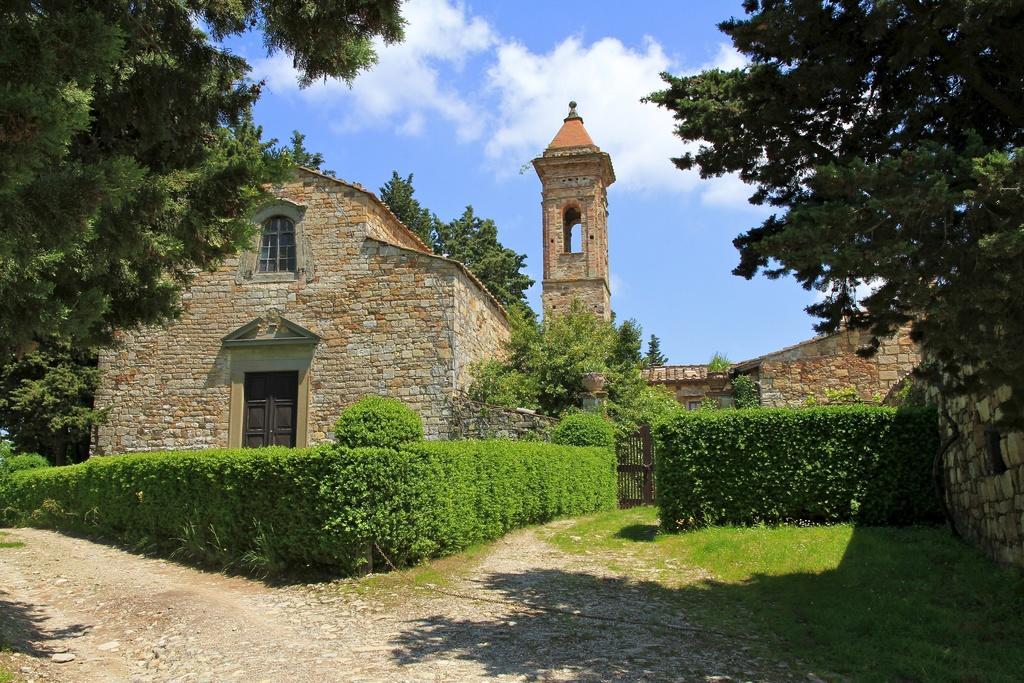How would you summarize this image in a sentence or two? There are some plants at the bottom of this image and there is a house in the background. There are some trees on the left side of this image and right side of this image as well. There is a cloudy sky at the top of this image. 